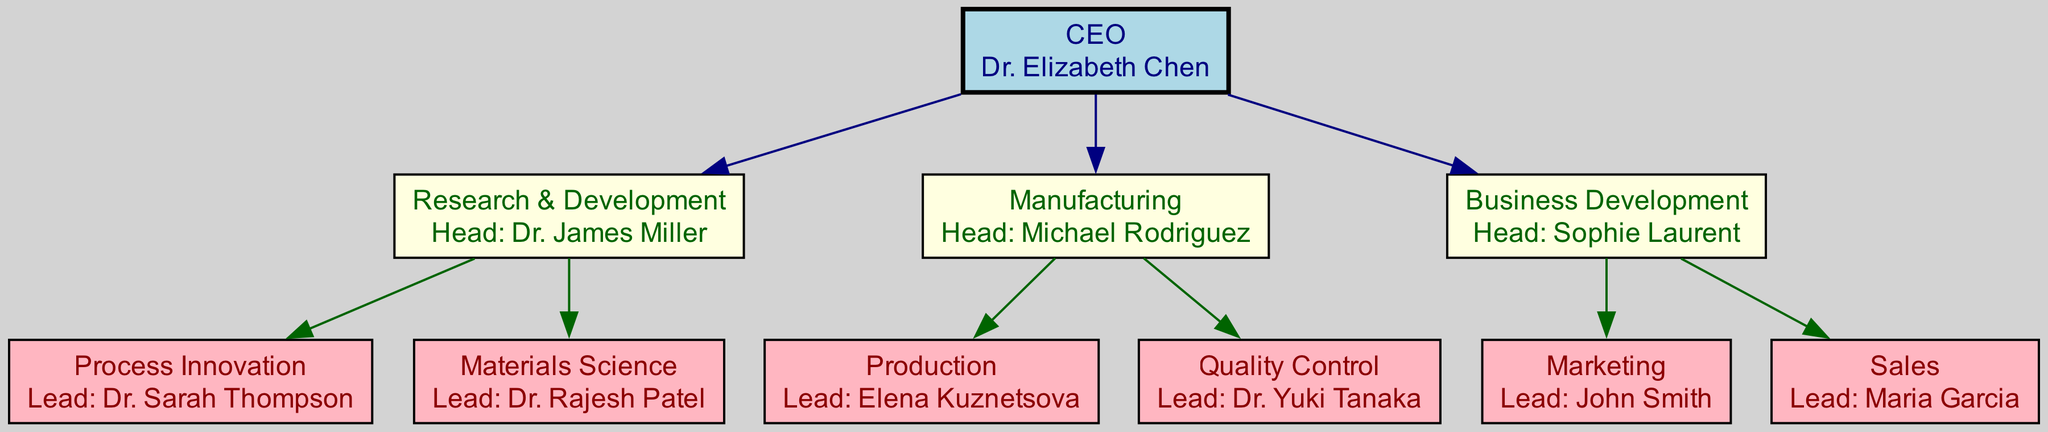What is the name of the CEO? The diagram identifies the CEO with a specific node labeled "CEO," which contains the name "Dr. Elizabeth Chen."
Answer: Dr. Elizabeth Chen Who leads the Process Innovation department? Within the hierarchy, under the Research & Development division, the Process Innovation department specifically lists its lead as "Dr. Sarah Thompson."
Answer: Dr. Sarah Thompson How many divisions are in the corporation? By inspecting the divisions listed in the diagram, there are three main divisions under the CEO: Research & Development, Manufacturing, and Business Development.
Answer: 3 Which division has the head named Michael Rodriguez? Examining the nodes, the division labeled "Manufacturing" clearly names "Michael Rodriguez" as its head.
Answer: Manufacturing What department is headed by Dr. Yuki Tanaka? The diagram lists the Quality Control department under the Manufacturing division, where Dr. Yuki Tanaka is identified as the lead.
Answer: Quality Control Which division is responsible for Marketing? Looking at the Business Development division in the diagram, Marketing is listed among its departments, but there is no associated lead for this inquiry, only the division name.
Answer: Business Development How many departments are there under the Manufacturing division? The Manufacturing division has two departments: Production and Quality Control. Therefore, by counting these departments, the answer is derived.
Answer: 2 What is the relationship between the CEO and the Research & Development division? The diagram shows a direct edge connecting the CEO node to the Research & Development division node, indicating that the CEO oversees this division.
Answer: Direct supervision Who is the lead of the Sales department? The department node for Sales identified in the Business Development division specifies Maria Garcia as the lead.
Answer: Maria Garcia 